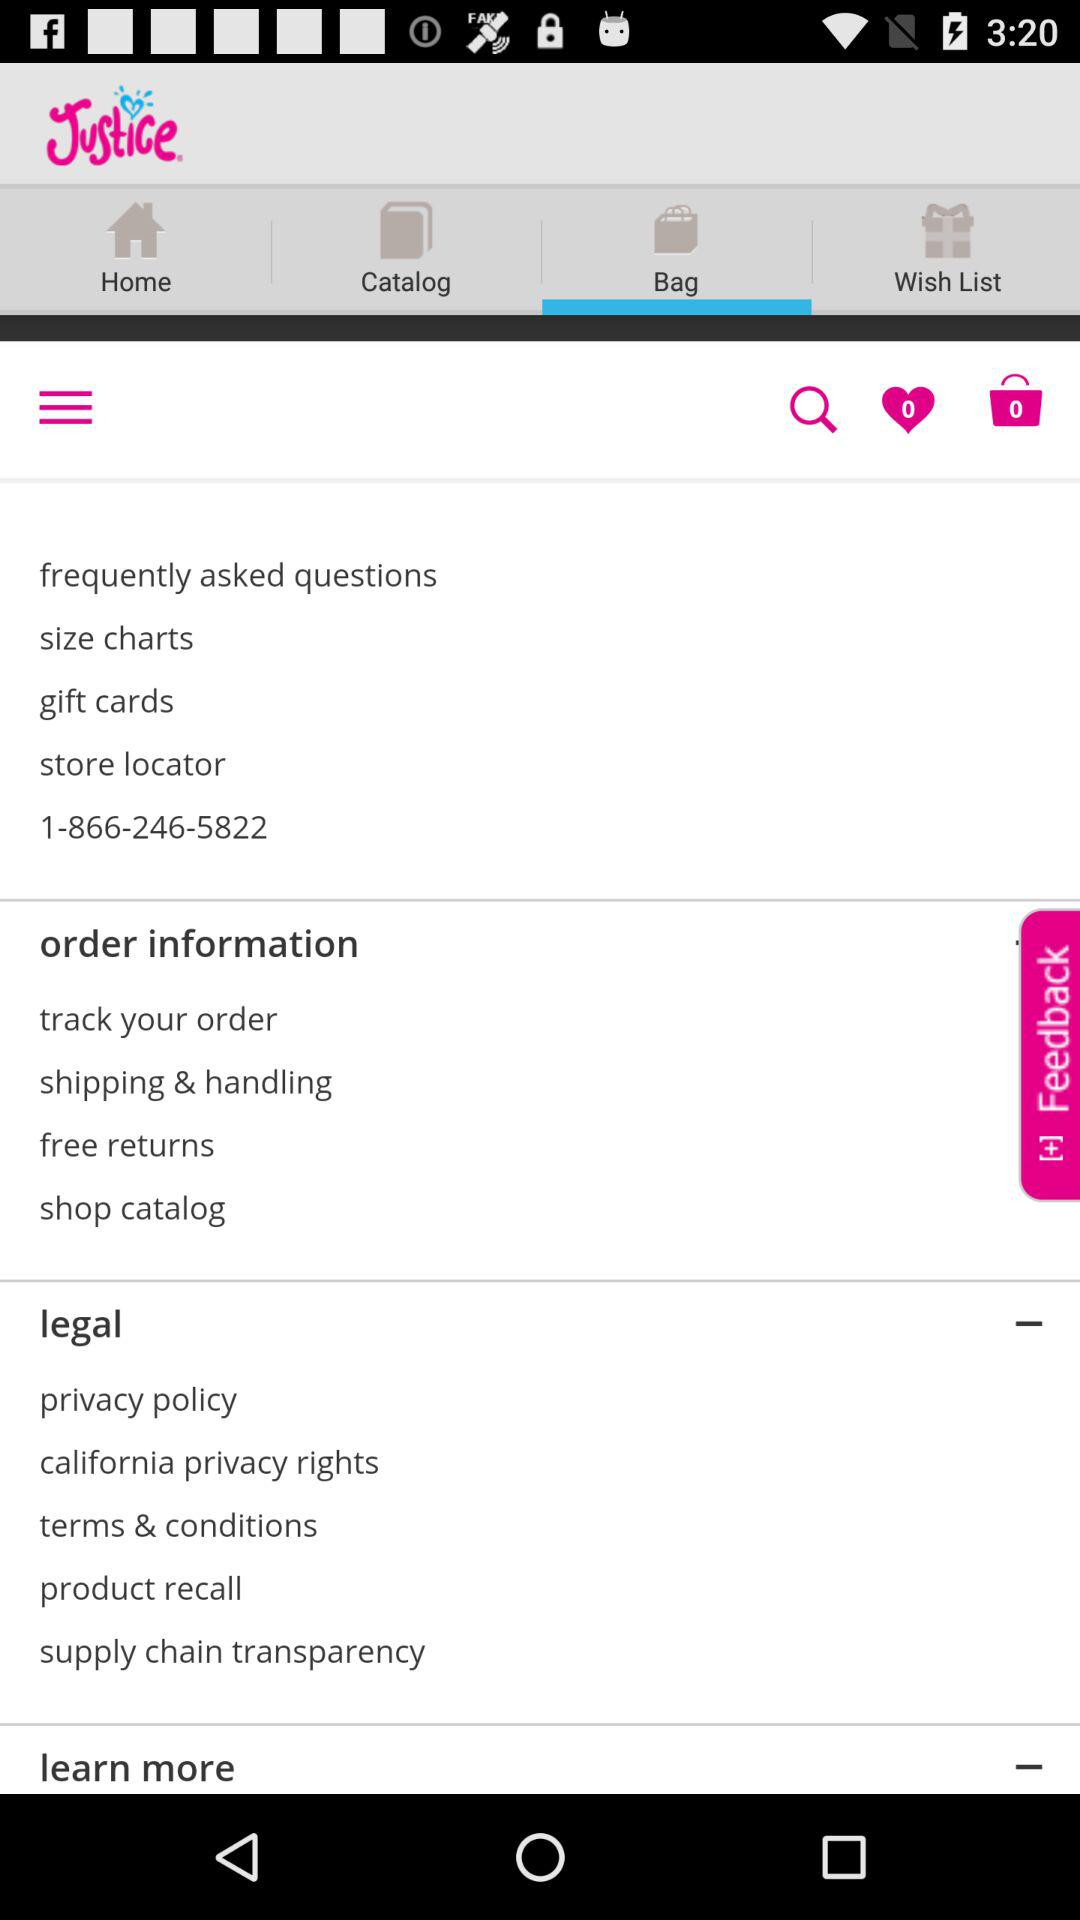How many items are on the wishlist? There are 0 items on the wishlist. 